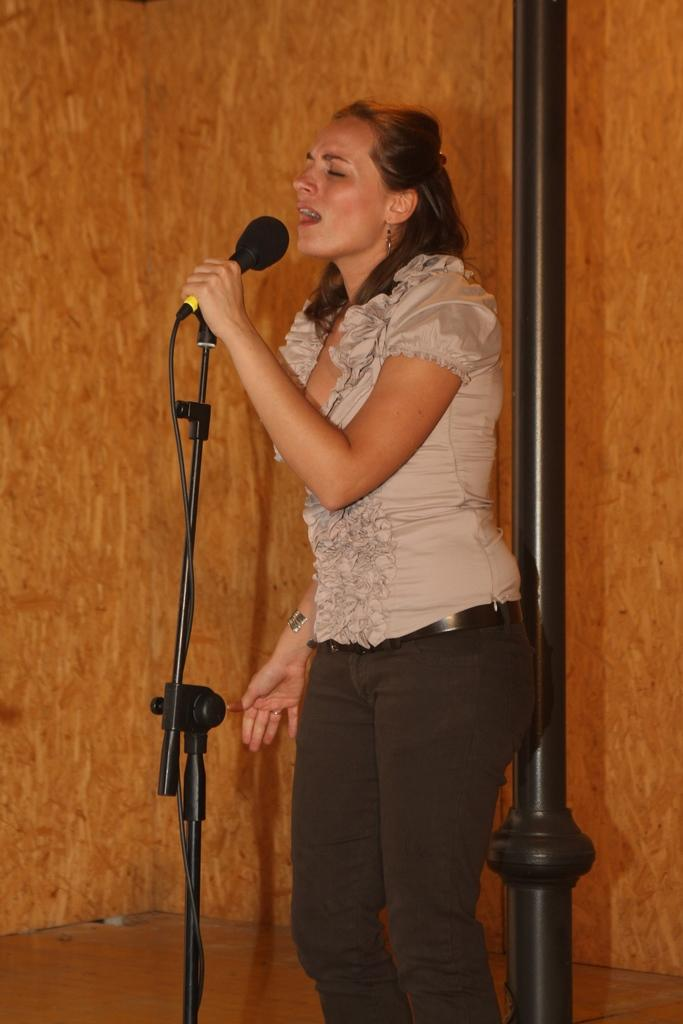Who is the main subject in the image? There is a lady in the image. What is the lady doing in the image? The lady is singing. What is the lady holding while singing? The lady is holding a black microphone. Can you describe the background of the image? There is a beautifully decorated brown background in the image. How does the kitty say good-bye in the image? There is no kitty present in the image, so it cannot be determined how a kitty might say good-bye. What type of acoustics can be observed in the image? The image does not provide information about the acoustics of the environment, so it cannot be determined from the image. 